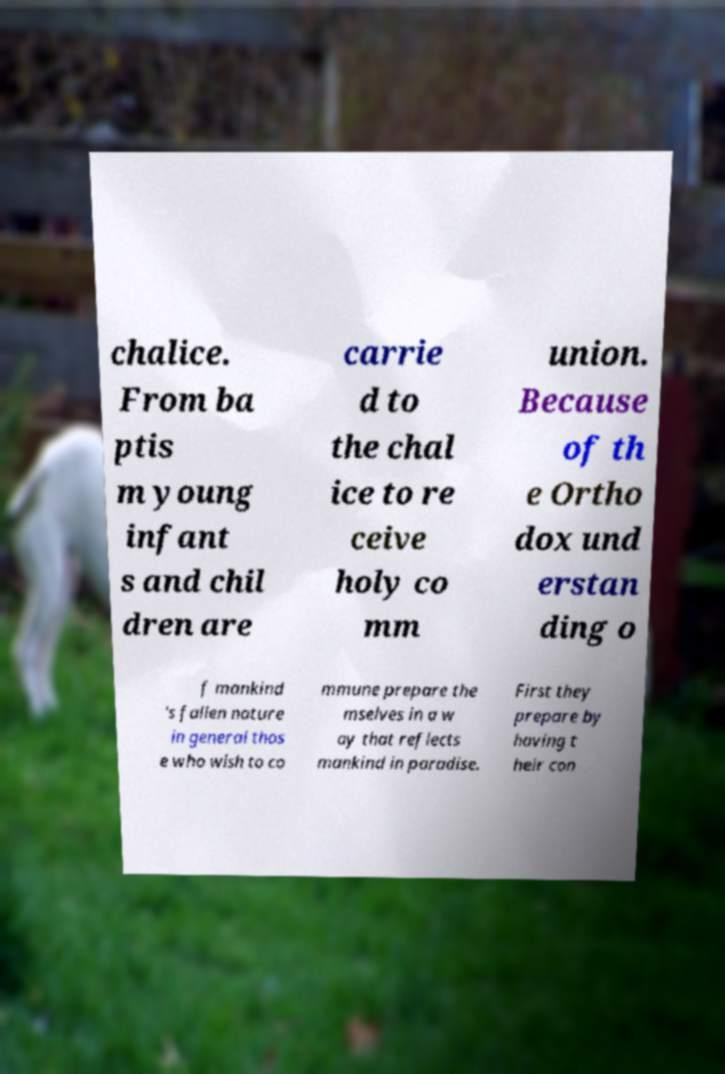Could you assist in decoding the text presented in this image and type it out clearly? chalice. From ba ptis m young infant s and chil dren are carrie d to the chal ice to re ceive holy co mm union. Because of th e Ortho dox und erstan ding o f mankind 's fallen nature in general thos e who wish to co mmune prepare the mselves in a w ay that reflects mankind in paradise. First they prepare by having t heir con 